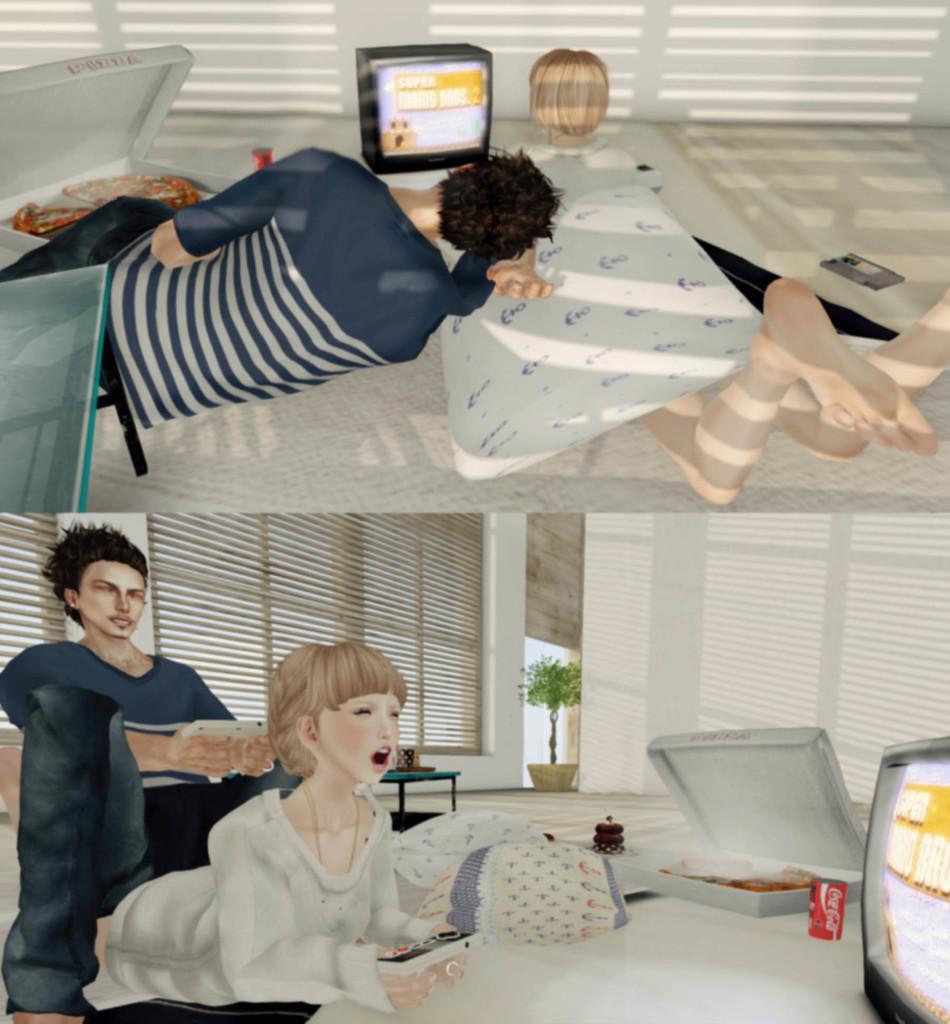Can you describe this image briefly? This animated image is collage of two different pictures. At the top there are two people lying on the floor. There is a carpet on the floor. In front of them there is a television. Beside the television there is a box. There is food in the box. At the bottom there is a person lying on the floor. Beside the person there is another person sitting. That person is holding a mobile phone in the hand. in the bottom right there is a television. Beside it there are food, a box and a drink can. There are window blinds to the wall. There are tables and a houseplant in the image. 